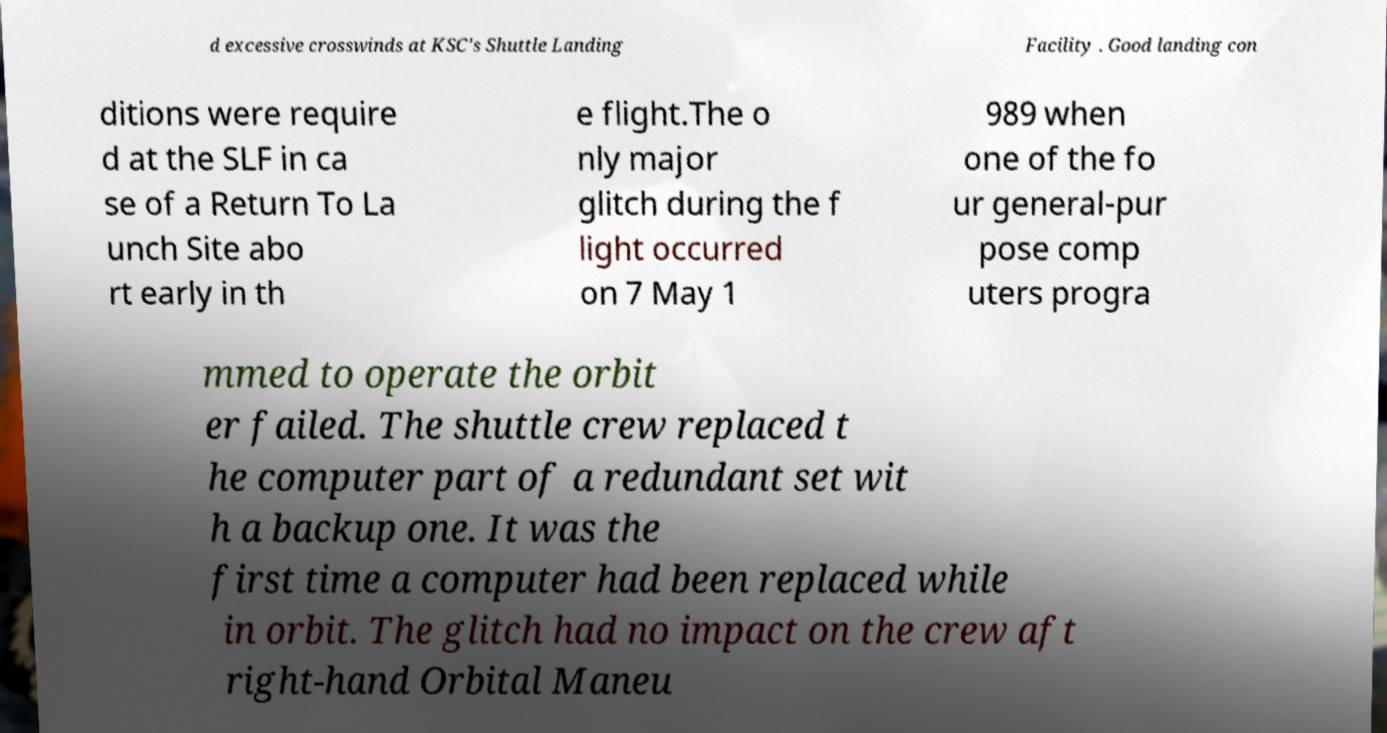Can you read and provide the text displayed in the image?This photo seems to have some interesting text. Can you extract and type it out for me? d excessive crosswinds at KSC's Shuttle Landing Facility . Good landing con ditions were require d at the SLF in ca se of a Return To La unch Site abo rt early in th e flight.The o nly major glitch during the f light occurred on 7 May 1 989 when one of the fo ur general-pur pose comp uters progra mmed to operate the orbit er failed. The shuttle crew replaced t he computer part of a redundant set wit h a backup one. It was the first time a computer had been replaced while in orbit. The glitch had no impact on the crew aft right-hand Orbital Maneu 